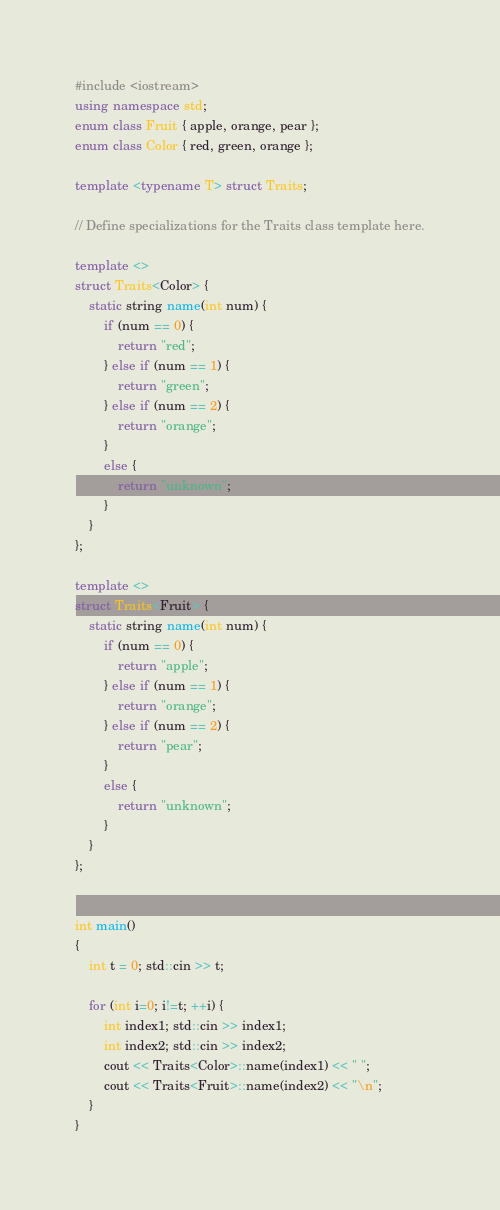Convert code to text. <code><loc_0><loc_0><loc_500><loc_500><_C++_>#include <iostream>
using namespace std;
enum class Fruit { apple, orange, pear };
enum class Color { red, green, orange };

template <typename T> struct Traits;

// Define specializations for the Traits class template here.

template <>
struct Traits<Color> {
    static string name(int num) {
        if (num == 0) {
            return "red";
        } else if (num == 1) {
            return "green";
        } else if (num == 2) {
            return "orange";
        }
        else {
            return "unknown";
        }
    }
};

template <>
struct Traits<Fruit> {
    static string name(int num) {
        if (num == 0) {
            return "apple";
        } else if (num == 1) {
            return "orange";
        } else if (num == 2) {
            return "pear";
        }
        else {
            return "unknown";
        }
    }
};


int main()
{
	int t = 0; std::cin >> t;

    for (int i=0; i!=t; ++i) {
        int index1; std::cin >> index1;
        int index2; std::cin >> index2;
        cout << Traits<Color>::name(index1) << " ";
        cout << Traits<Fruit>::name(index2) << "\n";
    }
}
</code> 